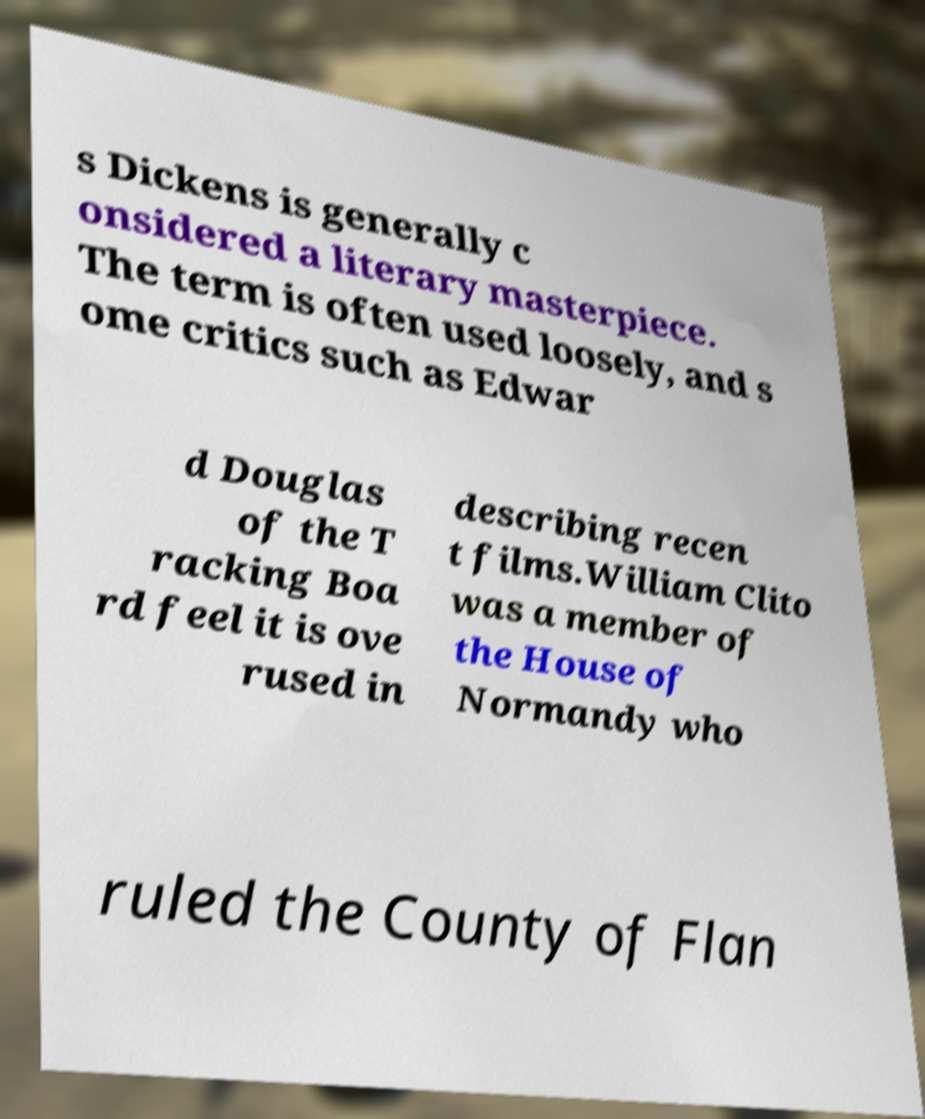For documentation purposes, I need the text within this image transcribed. Could you provide that? s Dickens is generally c onsidered a literary masterpiece. The term is often used loosely, and s ome critics such as Edwar d Douglas of the T racking Boa rd feel it is ove rused in describing recen t films.William Clito was a member of the House of Normandy who ruled the County of Flan 